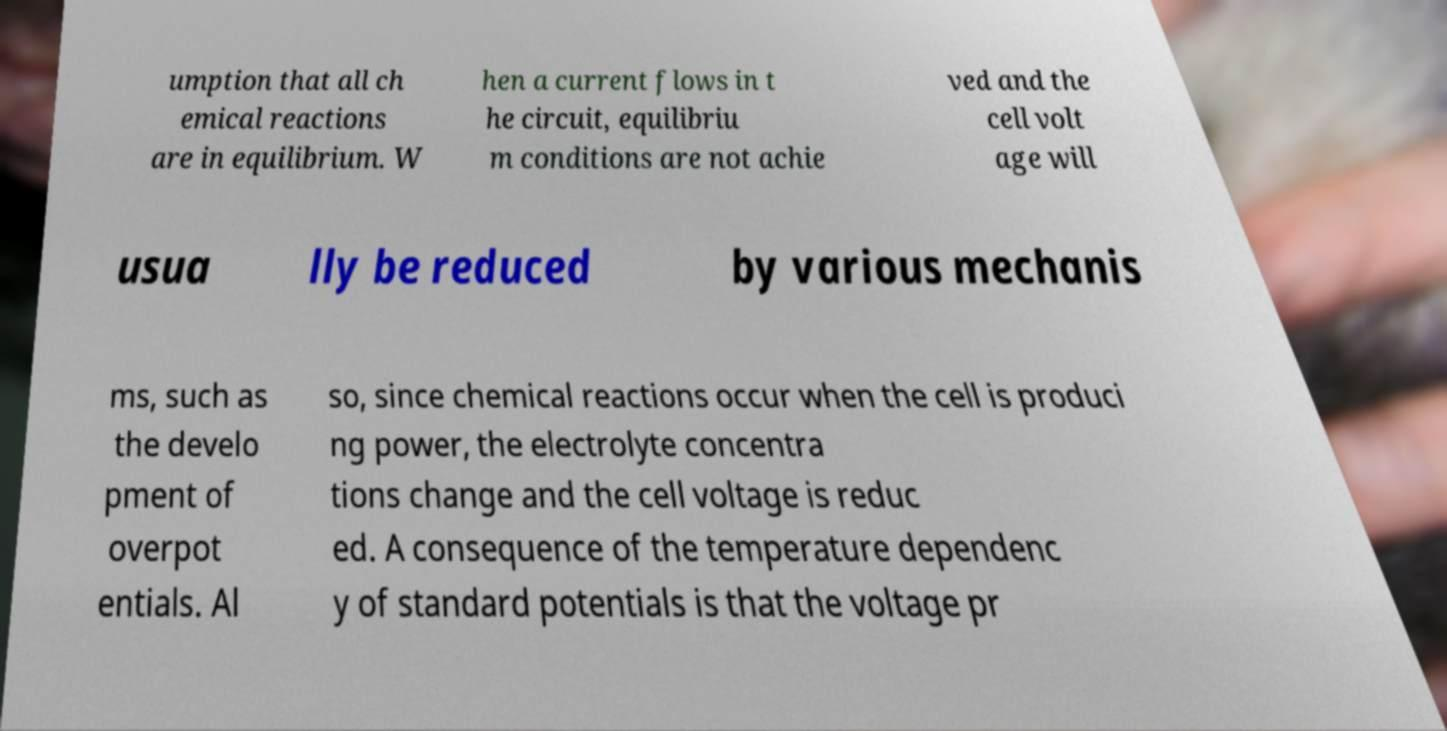I need the written content from this picture converted into text. Can you do that? umption that all ch emical reactions are in equilibrium. W hen a current flows in t he circuit, equilibriu m conditions are not achie ved and the cell volt age will usua lly be reduced by various mechanis ms, such as the develo pment of overpot entials. Al so, since chemical reactions occur when the cell is produci ng power, the electrolyte concentra tions change and the cell voltage is reduc ed. A consequence of the temperature dependenc y of standard potentials is that the voltage pr 